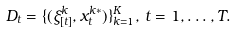Convert formula to latex. <formula><loc_0><loc_0><loc_500><loc_500>D _ { t } & = \{ ( \xi _ { [ t ] } ^ { k } , x _ { t } ^ { k * } ) \} _ { k = 1 } ^ { K } , \, t = 1 , \dots , T .</formula> 